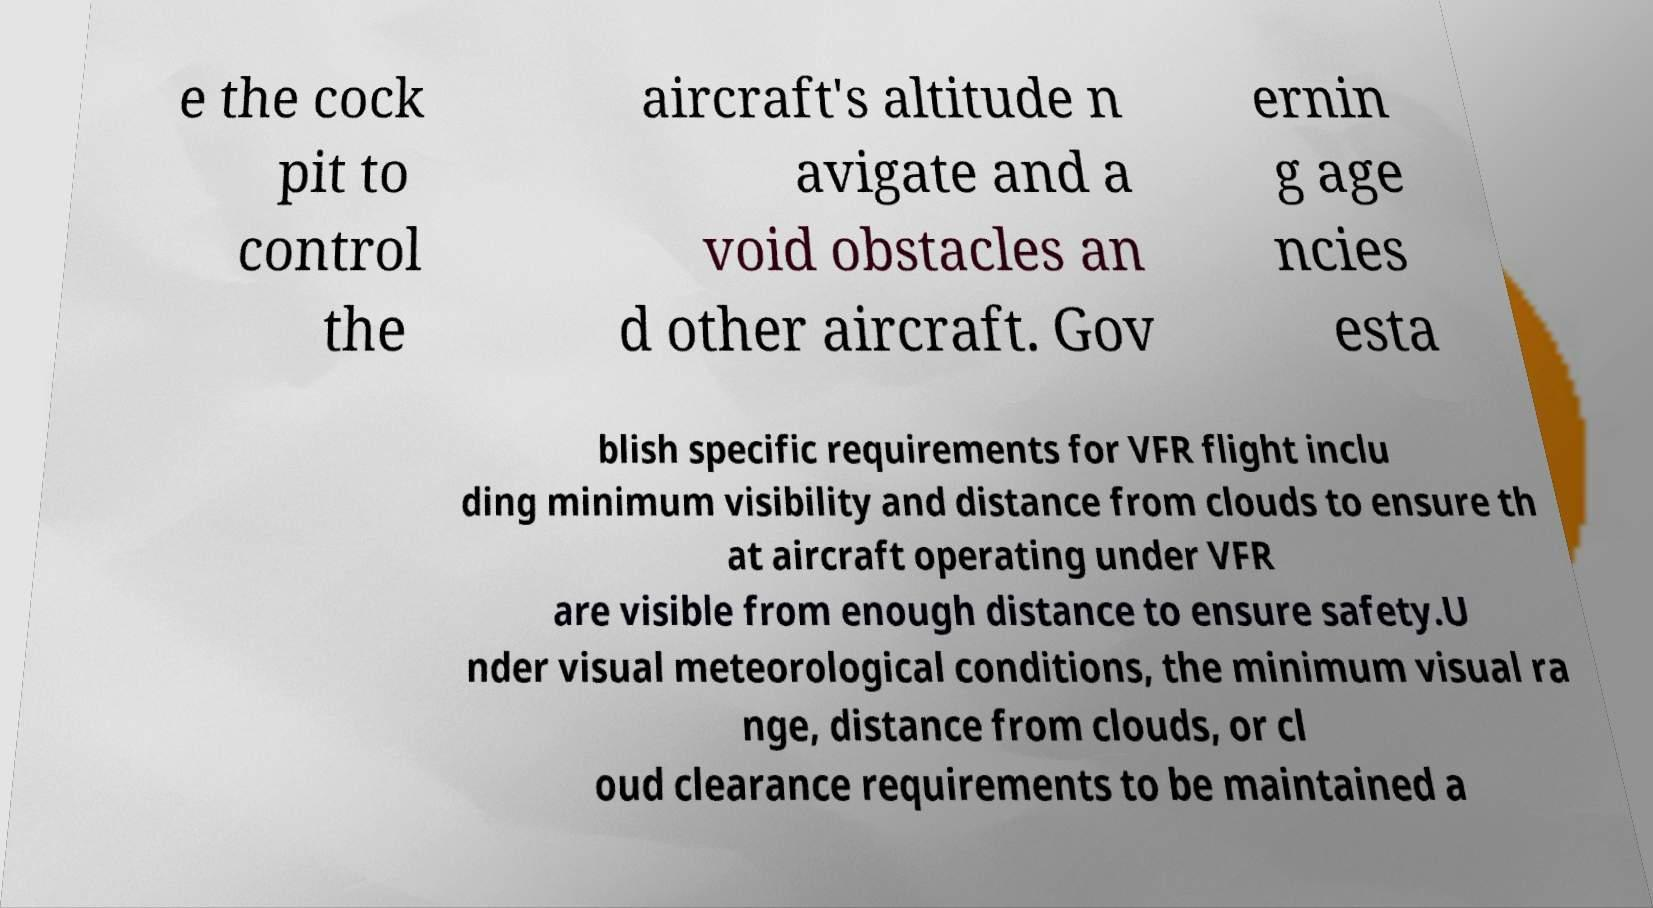I need the written content from this picture converted into text. Can you do that? e the cock pit to control the aircraft's altitude n avigate and a void obstacles an d other aircraft. Gov ernin g age ncies esta blish specific requirements for VFR flight inclu ding minimum visibility and distance from clouds to ensure th at aircraft operating under VFR are visible from enough distance to ensure safety.U nder visual meteorological conditions, the minimum visual ra nge, distance from clouds, or cl oud clearance requirements to be maintained a 